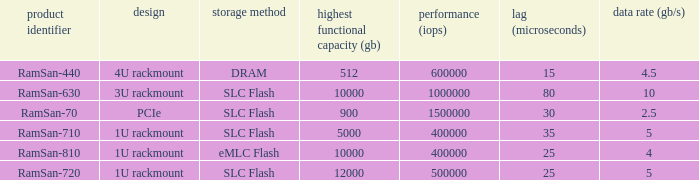List the number of ramsan-720 hard drives? 1.0. 